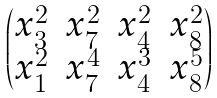<formula> <loc_0><loc_0><loc_500><loc_500>\begin{pmatrix} x _ { 3 } ^ { 2 } & x _ { 7 } ^ { 2 } & x _ { 4 } ^ { 2 } & x _ { 8 } ^ { 2 } \\ x _ { 1 } ^ { 2 } & x _ { 7 } ^ { 4 } & x _ { 4 } ^ { 3 } & x _ { 8 } ^ { 5 } \end{pmatrix}</formula> 